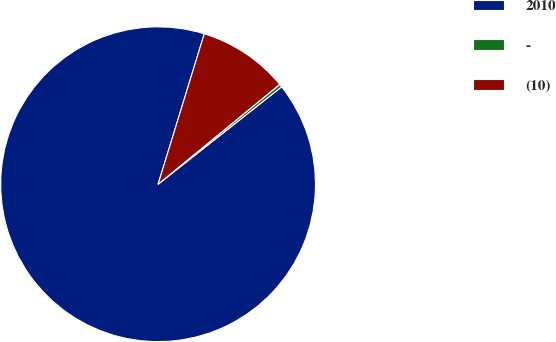Convert chart. <chart><loc_0><loc_0><loc_500><loc_500><pie_chart><fcel>2010<fcel>-<fcel>(10)<nl><fcel>90.37%<fcel>0.31%<fcel>9.32%<nl></chart> 